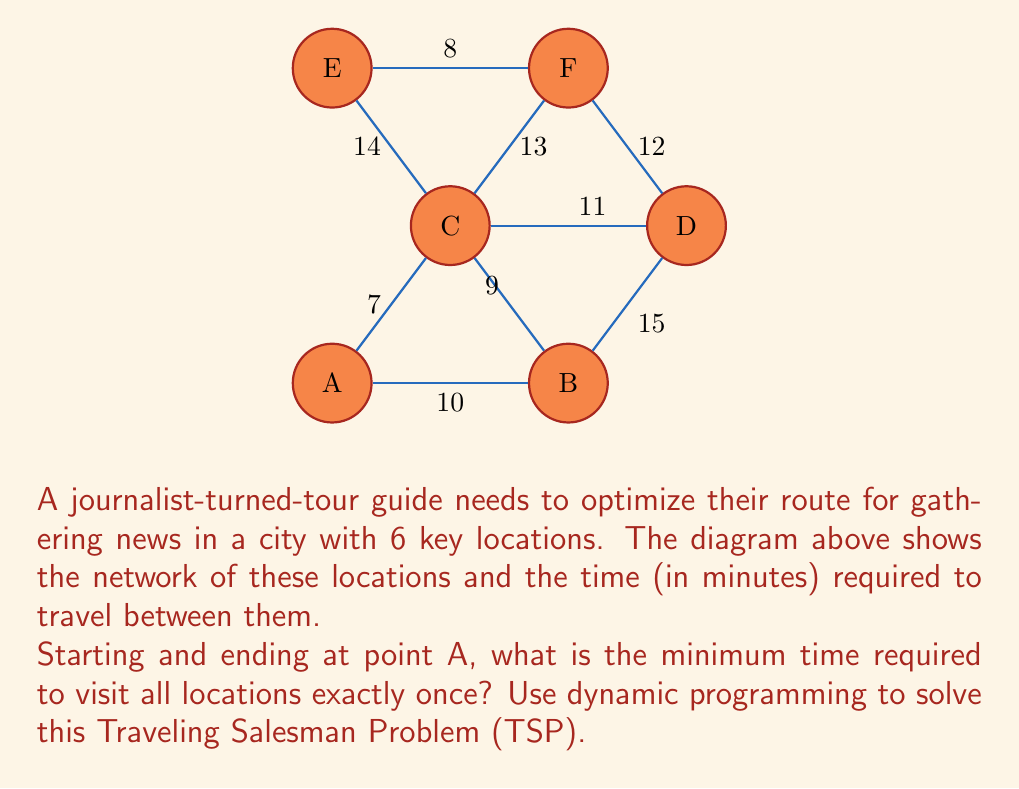Give your solution to this math problem. To solve this Traveling Salesman Problem using dynamic programming, we'll use the Held-Karp algorithm:

1) First, let's create a distance matrix for our graph:

   $$
   \begin{bmatrix}
   0 & 10 & 7 & \infty & \infty & \infty \\
   10 & 0 & 9 & 15 & \infty & \infty \\
   7 & 9 & 0 & 11 & 14 & 13 \\
   \infty & 15 & 11 & 0 & \infty & 12 \\
   \infty & \infty & 14 & \infty & 0 & 8 \\
   \infty & \infty & 13 & 12 & 8 & 0
   \end{bmatrix}
   $$

2) Initialize the base cases:
   For each vertex $v$, $C(\{v\}, v) = \text{distance}(0, v)$

3) For subsets $S$ of size 2 to n-1:
   For each vertex $v$ not in $S$:
   $$C(S \cup \{v\}, v) = \min_{u \in S} [C(S, u) + \text{distance}(u, v)]$$

4) Final step:
   $$\text{optimal tour} = \min_{v \neq 0} [C(V - \{0\}, v) + \text{distance}(v, 0)]$$

5) Applying the algorithm (abbreviated for space):
   $C(\{B\}, B) = 10$
   $C(\{C\}, C) = 7$
   $C(\{D\}, D) = \infty$
   $C(\{E\}, E) = \infty$
   $C(\{F\}, F) = \infty$

   $C(\{B,C\}, B) = \min[C(\{C\}, C) + d(C,B)] = 16$
   $C(\{B,C\}, C) = \min[C(\{B\}, B) + d(B,C)] = 19$
   ...

6) Final calculation:
   $\text{optimal tour} = \min[C(\{B,C,D,E,F\}, B) + d(B,A),$ 
                              $C(\{B,C,D,E,F\}, C) + d(C,A),$ 
                              $C(\{B,C,D,E,F\}, D) + d(D,A),$ 
                              $C(\{B,C,D,E,F\}, E) + d(E,A),$ 
                              $C(\{B,C,D,E,F\}, F) + d(F,A)]$

   $= \min[62, 59, 67, 66, 70] = 59$

The optimal tour is A-C-B-D-F-E-A with a total distance of 59.
Answer: 59 minutes 